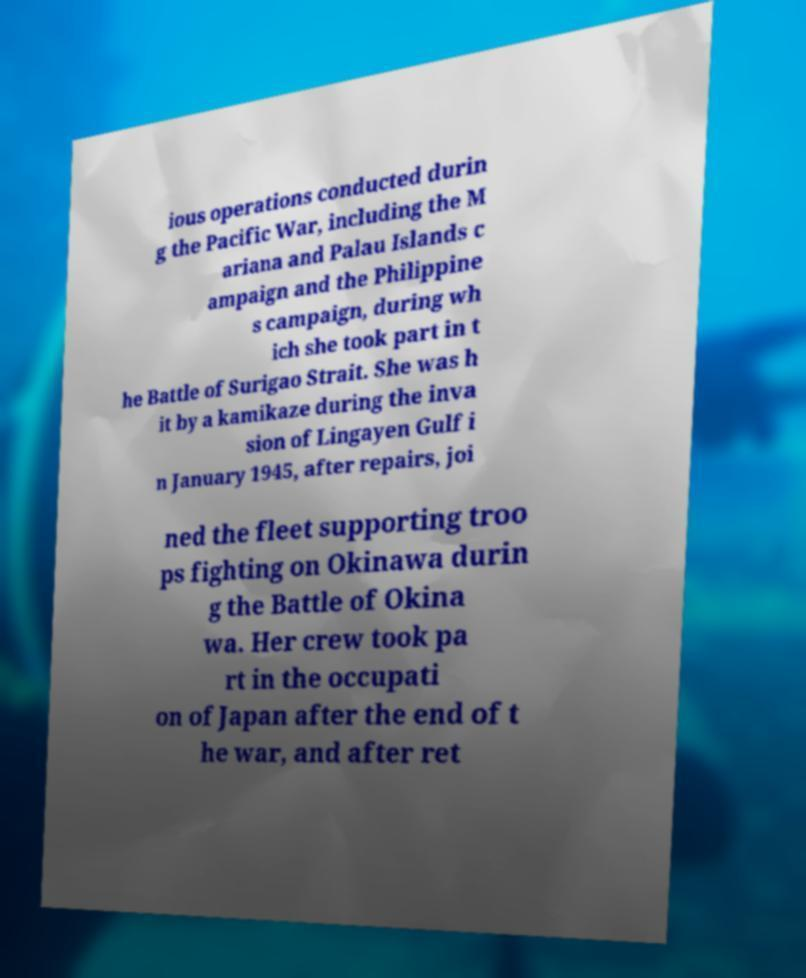Can you accurately transcribe the text from the provided image for me? ious operations conducted durin g the Pacific War, including the M ariana and Palau Islands c ampaign and the Philippine s campaign, during wh ich she took part in t he Battle of Surigao Strait. She was h it by a kamikaze during the inva sion of Lingayen Gulf i n January 1945, after repairs, joi ned the fleet supporting troo ps fighting on Okinawa durin g the Battle of Okina wa. Her crew took pa rt in the occupati on of Japan after the end of t he war, and after ret 